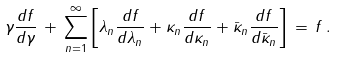<formula> <loc_0><loc_0><loc_500><loc_500>\gamma \frac { d f } { d \gamma } \, + \, \sum _ { n = 1 } ^ { \infty } \left [ \lambda _ { n } \frac { d f } { d \lambda _ { n } } + \kappa _ { n } \frac { d f } { d \kappa _ { n } } + \bar { \kappa } _ { n } \frac { d f } { d \bar { \kappa } _ { n } } \right ] \, = \, f \, .</formula> 